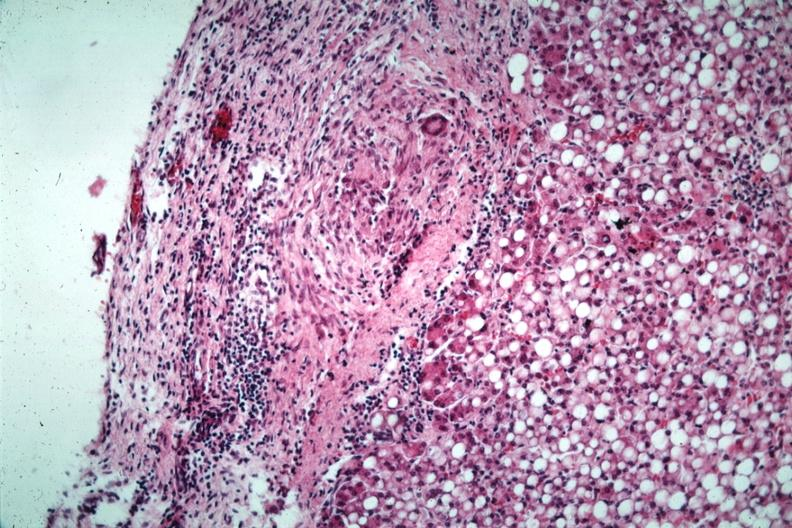what does this image show?
Answer the question using a single word or phrase. Liver with tuberculoid granuloma in glissons capsule quite good liver has marked fatty change 